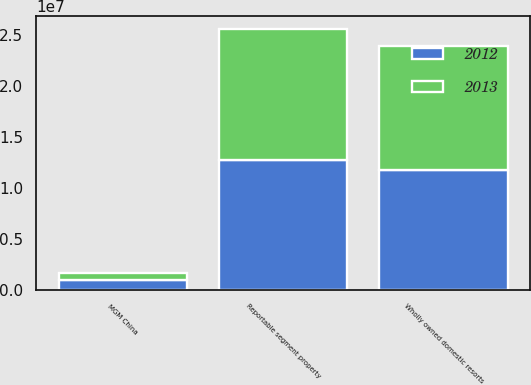Convert chart. <chart><loc_0><loc_0><loc_500><loc_500><stacked_bar_chart><ecel><fcel>Wholly owned domestic resorts<fcel>MGM China<fcel>Reportable segment property<nl><fcel>2012<fcel>1.17879e+07<fcel>957769<fcel>1.27456e+07<nl><fcel>2013<fcel>1.21457e+07<fcel>737920<fcel>1.28836e+07<nl></chart> 